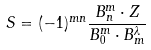Convert formula to latex. <formula><loc_0><loc_0><loc_500><loc_500>S = ( - 1 ) ^ { m n } \frac { B _ { n } ^ { m } \cdot { Z } } { B _ { 0 } ^ { m } \cdot { B } _ { m } ^ { \lambda } }</formula> 